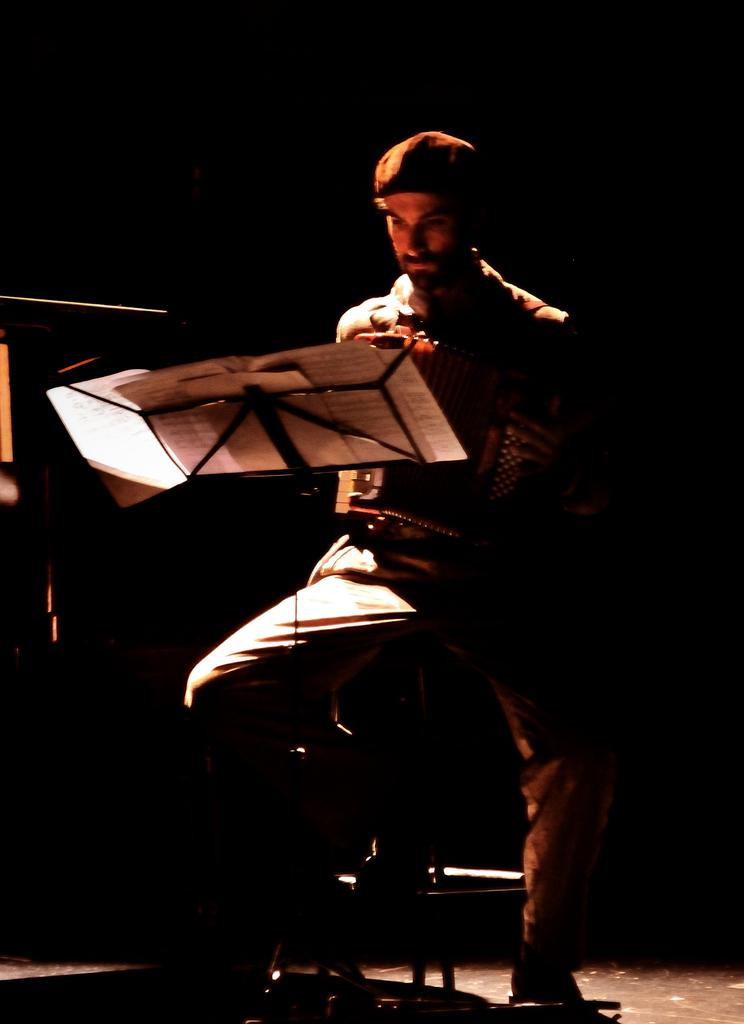Who or what is in the image? There is a person in the image. What is the person doing in the image? The person is sitting on a chair. What can be seen on the stand in front of the person? There are papers on the stand in front of the person. How many spiders are crawling on the person's arm in the image? There are no spiders visible in the image; the person's arm is not shown. 